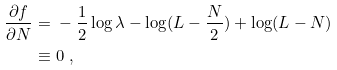Convert formula to latex. <formula><loc_0><loc_0><loc_500><loc_500>\frac { \partial f } { \partial N } = & \ - \frac { 1 } { 2 } \log \lambda - \log ( L - \frac { N } { 2 } ) + \log ( L - N ) \\ \equiv & \ 0 \ ,</formula> 